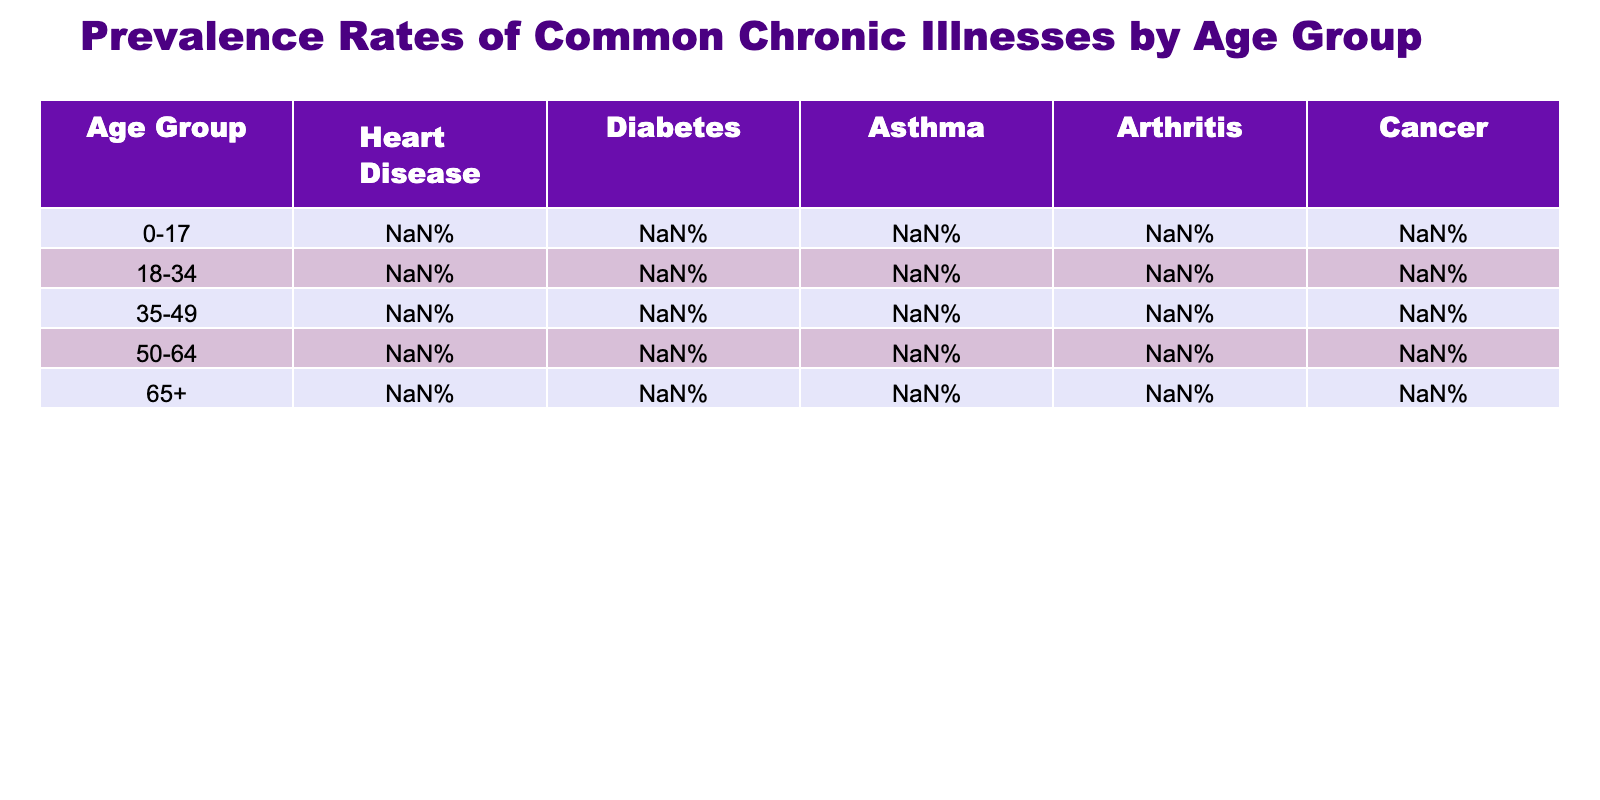What is the prevalence rate of diabetes in the 50-64 age group? Referring to the table, the rate is specifically listed under the diabetes column for the 50-64 age group, which shows 17.5%.
Answer: 17.5% Which age group has the highest prevalence of heart disease? By examining the heart disease row in the table, it's clear that the 65+ age group has the highest rate at 29.3%.
Answer: 65+ What is the difference in the prevalence of asthma between the 0-17 and 35-49 age groups? For the 0-17 age group, the asthma prevalence is 8.4%, and for the 35-49 age group, it is 7.9%. The difference is 8.4% - 7.9% = 0.5%.
Answer: 0.5% Is the prevalence of cancer higher in the 50-64 age group than in the 35-49 age group? Looking at the cancer rates, the 50-64 age group has a prevalence of 8.7% and the 35-49 age group has 3.5%. Since 8.7% is greater than 3.5%, the statement is true.
Answer: Yes What is the average prevalence of diabetes across all age groups listed? The diabetes prevalence rates are 0.24%, 3.7%, 9.2%, 17.5%, and 26.8%. Adding these gives 57.54%, and dividing by 5 for the average results in 57.54%/5 = 11.51%.
Answer: 11.51% Which chronic illness has the lowest prevalence rate in the 0-17 age group? In the 0-17 age group, the rates for heart disease (1.2%), diabetes (0.24%), asthma (8.4%), arthritis (0.3%), and cancer (0.1%) are compared. The lowest is the rate for cancer at 0.1%.
Answer: Cancer How does the prevalence of arthritis in the 65+ age group compare to that in the 18-34 age group? The prevalence of arthritis in the 65+ group is 49.6%, while in the 18-34 group it is 7.1%. The difference shows that 49.6% is significantly higher than 7.1%.
Answer: Higher What is the total prevalence percentage of chronic illnesses for the 35-49 age group? The prevalences for the 35-49 group are 11.8% (heart disease), 9.2% (diabetes), 7.9% (asthma), 15.6% (arthritis), and 3.5% (cancer). Adding these together yields a total of 47%.
Answer: 47% Is the rate of asthma in the 50-64 age group lower than that in the 18-34 age group? The prevalence of asthma in the 50-64 age group is 8.2%, while in the 18-34 age group it is 7.6%. Since 8.2% is greater than 7.6%, the statement is false.
Answer: No Which chronic illness has the highest overall prevalence in the 65+ age group? Observing the 65+ age group, the highest prevalence is found under arthritis at 49.6%. This is greater than all other illnesses listed.
Answer: Arthritis 